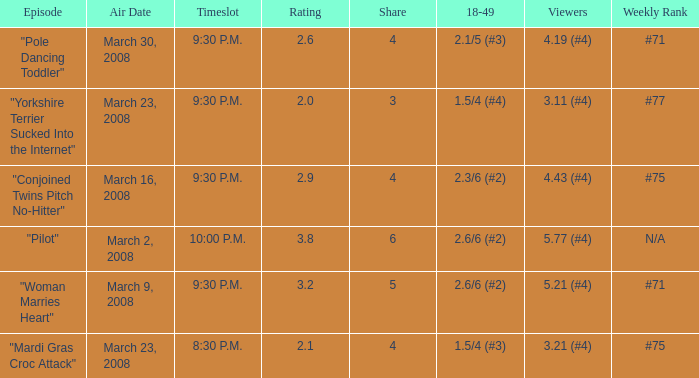What is the total ratings on share less than 4? 1.0. 